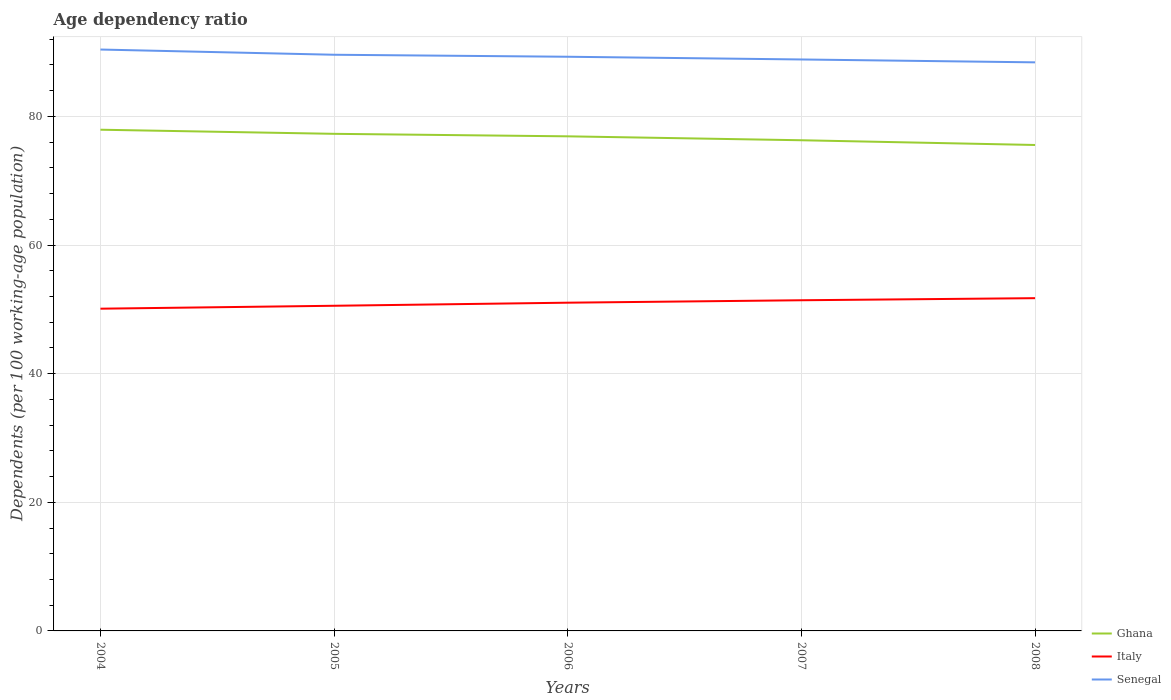How many different coloured lines are there?
Your answer should be compact. 3. Does the line corresponding to Italy intersect with the line corresponding to Senegal?
Provide a short and direct response. No. Across all years, what is the maximum age dependency ratio in in Senegal?
Offer a very short reply. 88.4. What is the total age dependency ratio in in Senegal in the graph?
Your answer should be very brief. 1.12. What is the difference between the highest and the second highest age dependency ratio in in Ghana?
Offer a terse response. 2.37. Is the age dependency ratio in in Italy strictly greater than the age dependency ratio in in Ghana over the years?
Provide a succinct answer. Yes. What is the difference between two consecutive major ticks on the Y-axis?
Make the answer very short. 20. Where does the legend appear in the graph?
Provide a short and direct response. Bottom right. How are the legend labels stacked?
Your answer should be very brief. Vertical. What is the title of the graph?
Provide a short and direct response. Age dependency ratio. What is the label or title of the X-axis?
Your answer should be compact. Years. What is the label or title of the Y-axis?
Offer a terse response. Dependents (per 100 working-age population). What is the Dependents (per 100 working-age population) in Ghana in 2004?
Provide a short and direct response. 77.92. What is the Dependents (per 100 working-age population) of Italy in 2004?
Make the answer very short. 50.1. What is the Dependents (per 100 working-age population) in Senegal in 2004?
Give a very brief answer. 90.39. What is the Dependents (per 100 working-age population) in Ghana in 2005?
Make the answer very short. 77.28. What is the Dependents (per 100 working-age population) in Italy in 2005?
Your response must be concise. 50.55. What is the Dependents (per 100 working-age population) of Senegal in 2005?
Your answer should be compact. 89.58. What is the Dependents (per 100 working-age population) of Ghana in 2006?
Provide a succinct answer. 76.9. What is the Dependents (per 100 working-age population) in Italy in 2006?
Give a very brief answer. 51.03. What is the Dependents (per 100 working-age population) of Senegal in 2006?
Give a very brief answer. 89.27. What is the Dependents (per 100 working-age population) of Ghana in 2007?
Provide a succinct answer. 76.29. What is the Dependents (per 100 working-age population) of Italy in 2007?
Your answer should be very brief. 51.41. What is the Dependents (per 100 working-age population) of Senegal in 2007?
Your answer should be compact. 88.84. What is the Dependents (per 100 working-age population) in Ghana in 2008?
Offer a very short reply. 75.55. What is the Dependents (per 100 working-age population) of Italy in 2008?
Offer a terse response. 51.73. What is the Dependents (per 100 working-age population) of Senegal in 2008?
Your answer should be very brief. 88.4. Across all years, what is the maximum Dependents (per 100 working-age population) of Ghana?
Provide a succinct answer. 77.92. Across all years, what is the maximum Dependents (per 100 working-age population) of Italy?
Keep it short and to the point. 51.73. Across all years, what is the maximum Dependents (per 100 working-age population) of Senegal?
Offer a very short reply. 90.39. Across all years, what is the minimum Dependents (per 100 working-age population) of Ghana?
Keep it short and to the point. 75.55. Across all years, what is the minimum Dependents (per 100 working-age population) in Italy?
Give a very brief answer. 50.1. Across all years, what is the minimum Dependents (per 100 working-age population) of Senegal?
Your answer should be compact. 88.4. What is the total Dependents (per 100 working-age population) of Ghana in the graph?
Provide a succinct answer. 383.94. What is the total Dependents (per 100 working-age population) in Italy in the graph?
Provide a succinct answer. 254.83. What is the total Dependents (per 100 working-age population) in Senegal in the graph?
Ensure brevity in your answer.  446.48. What is the difference between the Dependents (per 100 working-age population) in Ghana in 2004 and that in 2005?
Your response must be concise. 0.64. What is the difference between the Dependents (per 100 working-age population) of Italy in 2004 and that in 2005?
Your response must be concise. -0.45. What is the difference between the Dependents (per 100 working-age population) in Senegal in 2004 and that in 2005?
Your answer should be very brief. 0.81. What is the difference between the Dependents (per 100 working-age population) of Ghana in 2004 and that in 2006?
Provide a succinct answer. 1.03. What is the difference between the Dependents (per 100 working-age population) in Italy in 2004 and that in 2006?
Provide a succinct answer. -0.93. What is the difference between the Dependents (per 100 working-age population) in Senegal in 2004 and that in 2006?
Offer a very short reply. 1.12. What is the difference between the Dependents (per 100 working-age population) of Ghana in 2004 and that in 2007?
Give a very brief answer. 1.64. What is the difference between the Dependents (per 100 working-age population) of Italy in 2004 and that in 2007?
Give a very brief answer. -1.31. What is the difference between the Dependents (per 100 working-age population) of Senegal in 2004 and that in 2007?
Your response must be concise. 1.55. What is the difference between the Dependents (per 100 working-age population) in Ghana in 2004 and that in 2008?
Your response must be concise. 2.37. What is the difference between the Dependents (per 100 working-age population) in Italy in 2004 and that in 2008?
Make the answer very short. -1.63. What is the difference between the Dependents (per 100 working-age population) in Senegal in 2004 and that in 2008?
Provide a short and direct response. 1.99. What is the difference between the Dependents (per 100 working-age population) in Ghana in 2005 and that in 2006?
Provide a short and direct response. 0.39. What is the difference between the Dependents (per 100 working-age population) in Italy in 2005 and that in 2006?
Your answer should be very brief. -0.48. What is the difference between the Dependents (per 100 working-age population) of Senegal in 2005 and that in 2006?
Make the answer very short. 0.31. What is the difference between the Dependents (per 100 working-age population) of Ghana in 2005 and that in 2007?
Your answer should be compact. 1. What is the difference between the Dependents (per 100 working-age population) of Italy in 2005 and that in 2007?
Your answer should be very brief. -0.86. What is the difference between the Dependents (per 100 working-age population) of Senegal in 2005 and that in 2007?
Your response must be concise. 0.73. What is the difference between the Dependents (per 100 working-age population) of Ghana in 2005 and that in 2008?
Provide a short and direct response. 1.73. What is the difference between the Dependents (per 100 working-age population) of Italy in 2005 and that in 2008?
Offer a very short reply. -1.18. What is the difference between the Dependents (per 100 working-age population) of Senegal in 2005 and that in 2008?
Make the answer very short. 1.18. What is the difference between the Dependents (per 100 working-age population) of Ghana in 2006 and that in 2007?
Your response must be concise. 0.61. What is the difference between the Dependents (per 100 working-age population) in Italy in 2006 and that in 2007?
Offer a very short reply. -0.38. What is the difference between the Dependents (per 100 working-age population) of Senegal in 2006 and that in 2007?
Keep it short and to the point. 0.42. What is the difference between the Dependents (per 100 working-age population) of Ghana in 2006 and that in 2008?
Provide a short and direct response. 1.35. What is the difference between the Dependents (per 100 working-age population) in Italy in 2006 and that in 2008?
Offer a terse response. -0.7. What is the difference between the Dependents (per 100 working-age population) of Senegal in 2006 and that in 2008?
Offer a very short reply. 0.87. What is the difference between the Dependents (per 100 working-age population) of Ghana in 2007 and that in 2008?
Ensure brevity in your answer.  0.73. What is the difference between the Dependents (per 100 working-age population) of Italy in 2007 and that in 2008?
Keep it short and to the point. -0.32. What is the difference between the Dependents (per 100 working-age population) in Senegal in 2007 and that in 2008?
Offer a terse response. 0.45. What is the difference between the Dependents (per 100 working-age population) of Ghana in 2004 and the Dependents (per 100 working-age population) of Italy in 2005?
Ensure brevity in your answer.  27.37. What is the difference between the Dependents (per 100 working-age population) of Ghana in 2004 and the Dependents (per 100 working-age population) of Senegal in 2005?
Offer a terse response. -11.65. What is the difference between the Dependents (per 100 working-age population) of Italy in 2004 and the Dependents (per 100 working-age population) of Senegal in 2005?
Your answer should be compact. -39.48. What is the difference between the Dependents (per 100 working-age population) of Ghana in 2004 and the Dependents (per 100 working-age population) of Italy in 2006?
Offer a very short reply. 26.89. What is the difference between the Dependents (per 100 working-age population) in Ghana in 2004 and the Dependents (per 100 working-age population) in Senegal in 2006?
Make the answer very short. -11.34. What is the difference between the Dependents (per 100 working-age population) in Italy in 2004 and the Dependents (per 100 working-age population) in Senegal in 2006?
Your response must be concise. -39.17. What is the difference between the Dependents (per 100 working-age population) of Ghana in 2004 and the Dependents (per 100 working-age population) of Italy in 2007?
Your answer should be compact. 26.51. What is the difference between the Dependents (per 100 working-age population) of Ghana in 2004 and the Dependents (per 100 working-age population) of Senegal in 2007?
Ensure brevity in your answer.  -10.92. What is the difference between the Dependents (per 100 working-age population) of Italy in 2004 and the Dependents (per 100 working-age population) of Senegal in 2007?
Provide a succinct answer. -38.75. What is the difference between the Dependents (per 100 working-age population) of Ghana in 2004 and the Dependents (per 100 working-age population) of Italy in 2008?
Your response must be concise. 26.19. What is the difference between the Dependents (per 100 working-age population) in Ghana in 2004 and the Dependents (per 100 working-age population) in Senegal in 2008?
Provide a short and direct response. -10.47. What is the difference between the Dependents (per 100 working-age population) in Italy in 2004 and the Dependents (per 100 working-age population) in Senegal in 2008?
Your answer should be compact. -38.3. What is the difference between the Dependents (per 100 working-age population) in Ghana in 2005 and the Dependents (per 100 working-age population) in Italy in 2006?
Offer a terse response. 26.25. What is the difference between the Dependents (per 100 working-age population) of Ghana in 2005 and the Dependents (per 100 working-age population) of Senegal in 2006?
Offer a very short reply. -11.98. What is the difference between the Dependents (per 100 working-age population) in Italy in 2005 and the Dependents (per 100 working-age population) in Senegal in 2006?
Provide a short and direct response. -38.71. What is the difference between the Dependents (per 100 working-age population) of Ghana in 2005 and the Dependents (per 100 working-age population) of Italy in 2007?
Provide a short and direct response. 25.87. What is the difference between the Dependents (per 100 working-age population) of Ghana in 2005 and the Dependents (per 100 working-age population) of Senegal in 2007?
Make the answer very short. -11.56. What is the difference between the Dependents (per 100 working-age population) of Italy in 2005 and the Dependents (per 100 working-age population) of Senegal in 2007?
Your answer should be compact. -38.29. What is the difference between the Dependents (per 100 working-age population) in Ghana in 2005 and the Dependents (per 100 working-age population) in Italy in 2008?
Provide a short and direct response. 25.55. What is the difference between the Dependents (per 100 working-age population) of Ghana in 2005 and the Dependents (per 100 working-age population) of Senegal in 2008?
Offer a very short reply. -11.11. What is the difference between the Dependents (per 100 working-age population) in Italy in 2005 and the Dependents (per 100 working-age population) in Senegal in 2008?
Keep it short and to the point. -37.84. What is the difference between the Dependents (per 100 working-age population) in Ghana in 2006 and the Dependents (per 100 working-age population) in Italy in 2007?
Offer a terse response. 25.49. What is the difference between the Dependents (per 100 working-age population) in Ghana in 2006 and the Dependents (per 100 working-age population) in Senegal in 2007?
Provide a short and direct response. -11.95. What is the difference between the Dependents (per 100 working-age population) of Italy in 2006 and the Dependents (per 100 working-age population) of Senegal in 2007?
Provide a succinct answer. -37.81. What is the difference between the Dependents (per 100 working-age population) in Ghana in 2006 and the Dependents (per 100 working-age population) in Italy in 2008?
Provide a short and direct response. 25.16. What is the difference between the Dependents (per 100 working-age population) in Ghana in 2006 and the Dependents (per 100 working-age population) in Senegal in 2008?
Offer a terse response. -11.5. What is the difference between the Dependents (per 100 working-age population) in Italy in 2006 and the Dependents (per 100 working-age population) in Senegal in 2008?
Give a very brief answer. -37.37. What is the difference between the Dependents (per 100 working-age population) of Ghana in 2007 and the Dependents (per 100 working-age population) of Italy in 2008?
Give a very brief answer. 24.55. What is the difference between the Dependents (per 100 working-age population) of Ghana in 2007 and the Dependents (per 100 working-age population) of Senegal in 2008?
Ensure brevity in your answer.  -12.11. What is the difference between the Dependents (per 100 working-age population) in Italy in 2007 and the Dependents (per 100 working-age population) in Senegal in 2008?
Offer a very short reply. -36.99. What is the average Dependents (per 100 working-age population) in Ghana per year?
Offer a terse response. 76.79. What is the average Dependents (per 100 working-age population) in Italy per year?
Make the answer very short. 50.97. What is the average Dependents (per 100 working-age population) of Senegal per year?
Your response must be concise. 89.3. In the year 2004, what is the difference between the Dependents (per 100 working-age population) in Ghana and Dependents (per 100 working-age population) in Italy?
Make the answer very short. 27.83. In the year 2004, what is the difference between the Dependents (per 100 working-age population) in Ghana and Dependents (per 100 working-age population) in Senegal?
Give a very brief answer. -12.47. In the year 2004, what is the difference between the Dependents (per 100 working-age population) of Italy and Dependents (per 100 working-age population) of Senegal?
Give a very brief answer. -40.29. In the year 2005, what is the difference between the Dependents (per 100 working-age population) of Ghana and Dependents (per 100 working-age population) of Italy?
Keep it short and to the point. 26.73. In the year 2005, what is the difference between the Dependents (per 100 working-age population) of Ghana and Dependents (per 100 working-age population) of Senegal?
Offer a very short reply. -12.29. In the year 2005, what is the difference between the Dependents (per 100 working-age population) of Italy and Dependents (per 100 working-age population) of Senegal?
Keep it short and to the point. -39.03. In the year 2006, what is the difference between the Dependents (per 100 working-age population) of Ghana and Dependents (per 100 working-age population) of Italy?
Make the answer very short. 25.86. In the year 2006, what is the difference between the Dependents (per 100 working-age population) of Ghana and Dependents (per 100 working-age population) of Senegal?
Offer a terse response. -12.37. In the year 2006, what is the difference between the Dependents (per 100 working-age population) of Italy and Dependents (per 100 working-age population) of Senegal?
Your response must be concise. -38.23. In the year 2007, what is the difference between the Dependents (per 100 working-age population) of Ghana and Dependents (per 100 working-age population) of Italy?
Your answer should be very brief. 24.88. In the year 2007, what is the difference between the Dependents (per 100 working-age population) of Ghana and Dependents (per 100 working-age population) of Senegal?
Your answer should be compact. -12.56. In the year 2007, what is the difference between the Dependents (per 100 working-age population) of Italy and Dependents (per 100 working-age population) of Senegal?
Offer a terse response. -37.43. In the year 2008, what is the difference between the Dependents (per 100 working-age population) of Ghana and Dependents (per 100 working-age population) of Italy?
Keep it short and to the point. 23.82. In the year 2008, what is the difference between the Dependents (per 100 working-age population) of Ghana and Dependents (per 100 working-age population) of Senegal?
Offer a very short reply. -12.85. In the year 2008, what is the difference between the Dependents (per 100 working-age population) of Italy and Dependents (per 100 working-age population) of Senegal?
Keep it short and to the point. -36.66. What is the ratio of the Dependents (per 100 working-age population) in Ghana in 2004 to that in 2005?
Keep it short and to the point. 1.01. What is the ratio of the Dependents (per 100 working-age population) in Senegal in 2004 to that in 2005?
Your response must be concise. 1.01. What is the ratio of the Dependents (per 100 working-age population) of Ghana in 2004 to that in 2006?
Make the answer very short. 1.01. What is the ratio of the Dependents (per 100 working-age population) of Italy in 2004 to that in 2006?
Your answer should be very brief. 0.98. What is the ratio of the Dependents (per 100 working-age population) in Senegal in 2004 to that in 2006?
Offer a terse response. 1.01. What is the ratio of the Dependents (per 100 working-age population) in Ghana in 2004 to that in 2007?
Your answer should be very brief. 1.02. What is the ratio of the Dependents (per 100 working-age population) in Italy in 2004 to that in 2007?
Your answer should be very brief. 0.97. What is the ratio of the Dependents (per 100 working-age population) in Senegal in 2004 to that in 2007?
Ensure brevity in your answer.  1.02. What is the ratio of the Dependents (per 100 working-age population) in Ghana in 2004 to that in 2008?
Ensure brevity in your answer.  1.03. What is the ratio of the Dependents (per 100 working-age population) of Italy in 2004 to that in 2008?
Provide a succinct answer. 0.97. What is the ratio of the Dependents (per 100 working-age population) in Senegal in 2004 to that in 2008?
Make the answer very short. 1.02. What is the ratio of the Dependents (per 100 working-age population) of Italy in 2005 to that in 2006?
Your answer should be compact. 0.99. What is the ratio of the Dependents (per 100 working-age population) in Senegal in 2005 to that in 2006?
Your response must be concise. 1. What is the ratio of the Dependents (per 100 working-age population) of Ghana in 2005 to that in 2007?
Your answer should be very brief. 1.01. What is the ratio of the Dependents (per 100 working-age population) in Italy in 2005 to that in 2007?
Your answer should be very brief. 0.98. What is the ratio of the Dependents (per 100 working-age population) in Senegal in 2005 to that in 2007?
Keep it short and to the point. 1.01. What is the ratio of the Dependents (per 100 working-age population) of Italy in 2005 to that in 2008?
Offer a terse response. 0.98. What is the ratio of the Dependents (per 100 working-age population) in Senegal in 2005 to that in 2008?
Give a very brief answer. 1.01. What is the ratio of the Dependents (per 100 working-age population) in Senegal in 2006 to that in 2007?
Give a very brief answer. 1. What is the ratio of the Dependents (per 100 working-age population) in Ghana in 2006 to that in 2008?
Ensure brevity in your answer.  1.02. What is the ratio of the Dependents (per 100 working-age population) of Italy in 2006 to that in 2008?
Offer a terse response. 0.99. What is the ratio of the Dependents (per 100 working-age population) of Senegal in 2006 to that in 2008?
Offer a terse response. 1.01. What is the ratio of the Dependents (per 100 working-age population) of Ghana in 2007 to that in 2008?
Offer a very short reply. 1.01. What is the difference between the highest and the second highest Dependents (per 100 working-age population) of Ghana?
Provide a succinct answer. 0.64. What is the difference between the highest and the second highest Dependents (per 100 working-age population) of Italy?
Provide a succinct answer. 0.32. What is the difference between the highest and the second highest Dependents (per 100 working-age population) of Senegal?
Ensure brevity in your answer.  0.81. What is the difference between the highest and the lowest Dependents (per 100 working-age population) in Ghana?
Offer a very short reply. 2.37. What is the difference between the highest and the lowest Dependents (per 100 working-age population) of Italy?
Give a very brief answer. 1.63. What is the difference between the highest and the lowest Dependents (per 100 working-age population) in Senegal?
Provide a succinct answer. 1.99. 